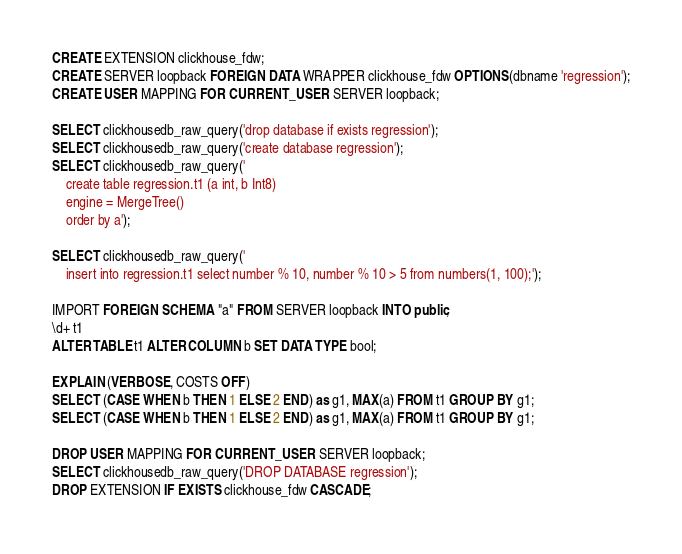<code> <loc_0><loc_0><loc_500><loc_500><_SQL_>CREATE EXTENSION clickhouse_fdw;
CREATE SERVER loopback FOREIGN DATA WRAPPER clickhouse_fdw OPTIONS(dbname 'regression');
CREATE USER MAPPING FOR CURRENT_USER SERVER loopback;

SELECT clickhousedb_raw_query('drop database if exists regression');
SELECT clickhousedb_raw_query('create database regression');
SELECT clickhousedb_raw_query('
	create table regression.t1 (a int, b Int8)
	engine = MergeTree()
	order by a');

SELECT clickhousedb_raw_query('
	insert into regression.t1 select number % 10, number % 10 > 5 from numbers(1, 100);');

IMPORT FOREIGN SCHEMA "a" FROM SERVER loopback INTO public;
\d+ t1
ALTER TABLE t1 ALTER COLUMN b SET DATA TYPE bool;

EXPLAIN (VERBOSE, COSTS OFF)
SELECT (CASE WHEN b THEN 1 ELSE 2 END) as g1, MAX(a) FROM t1 GROUP BY g1;
SELECT (CASE WHEN b THEN 1 ELSE 2 END) as g1, MAX(a) FROM t1 GROUP BY g1;

DROP USER MAPPING FOR CURRENT_USER SERVER loopback;
SELECT clickhousedb_raw_query('DROP DATABASE regression');
DROP EXTENSION IF EXISTS clickhouse_fdw CASCADE;
</code> 